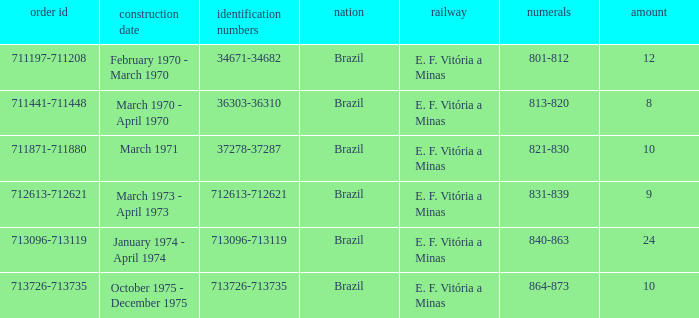The order number 713726-713735 has what serial number? 713726-713735. Could you parse the entire table as a dict? {'header': ['order id', 'construction date', 'identification numbers', 'nation', 'railway', 'numerals', 'amount'], 'rows': [['711197-711208', 'February 1970 - March 1970', '34671-34682', 'Brazil', 'E. F. Vitória a Minas', '801-812', '12'], ['711441-711448', 'March 1970 - April 1970', '36303-36310', 'Brazil', 'E. F. Vitória a Minas', '813-820', '8'], ['711871-711880', 'March 1971', '37278-37287', 'Brazil', 'E. F. Vitória a Minas', '821-830', '10'], ['712613-712621', 'March 1973 - April 1973', '712613-712621', 'Brazil', 'E. F. Vitória a Minas', '831-839', '9'], ['713096-713119', 'January 1974 - April 1974', '713096-713119', 'Brazil', 'E. F. Vitória a Minas', '840-863', '24'], ['713726-713735', 'October 1975 - December 1975', '713726-713735', 'Brazil', 'E. F. Vitória a Minas', '864-873', '10']]} 